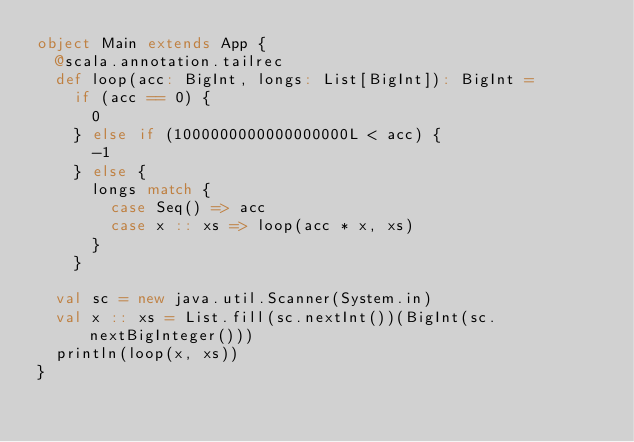<code> <loc_0><loc_0><loc_500><loc_500><_Scala_>object Main extends App {
  @scala.annotation.tailrec
  def loop(acc: BigInt, longs: List[BigInt]): BigInt =
    if (acc == 0) {
      0
    } else if (1000000000000000000L < acc) {
      -1
    } else {
      longs match {
        case Seq() => acc
        case x :: xs => loop(acc * x, xs)
      }
    }

  val sc = new java.util.Scanner(System.in)
  val x :: xs = List.fill(sc.nextInt())(BigInt(sc.nextBigInteger()))
  println(loop(x, xs))
}
</code> 